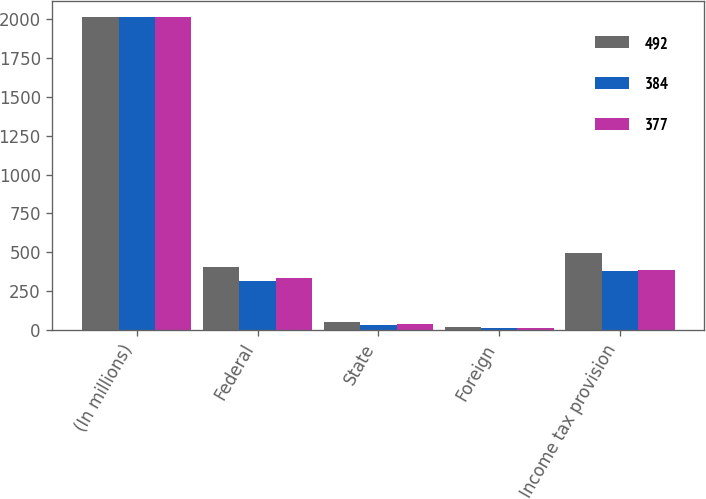Convert chart. <chart><loc_0><loc_0><loc_500><loc_500><stacked_bar_chart><ecel><fcel>(In millions)<fcel>Federal<fcel>State<fcel>Foreign<fcel>Income tax provision<nl><fcel>492<fcel>2016<fcel>402<fcel>53<fcel>16<fcel>492<nl><fcel>384<fcel>2015<fcel>315<fcel>31<fcel>11<fcel>377<nl><fcel>377<fcel>2014<fcel>331<fcel>40<fcel>10<fcel>384<nl></chart> 